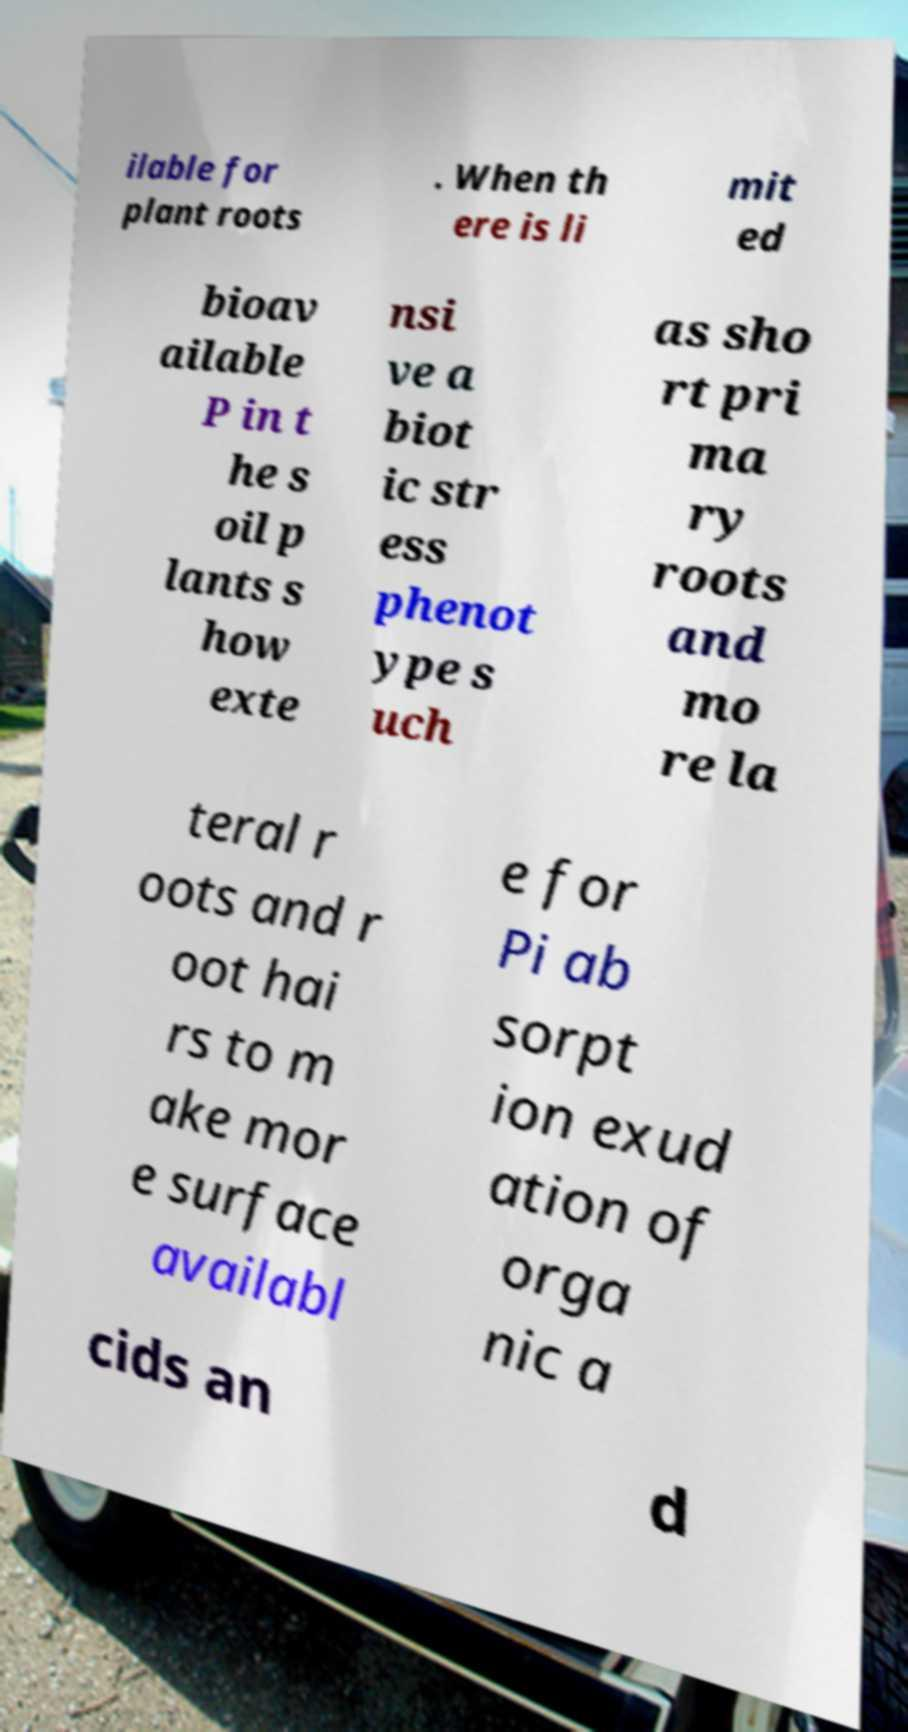Please identify and transcribe the text found in this image. ilable for plant roots . When th ere is li mit ed bioav ailable P in t he s oil p lants s how exte nsi ve a biot ic str ess phenot ype s uch as sho rt pri ma ry roots and mo re la teral r oots and r oot hai rs to m ake mor e surface availabl e for Pi ab sorpt ion exud ation of orga nic a cids an d 